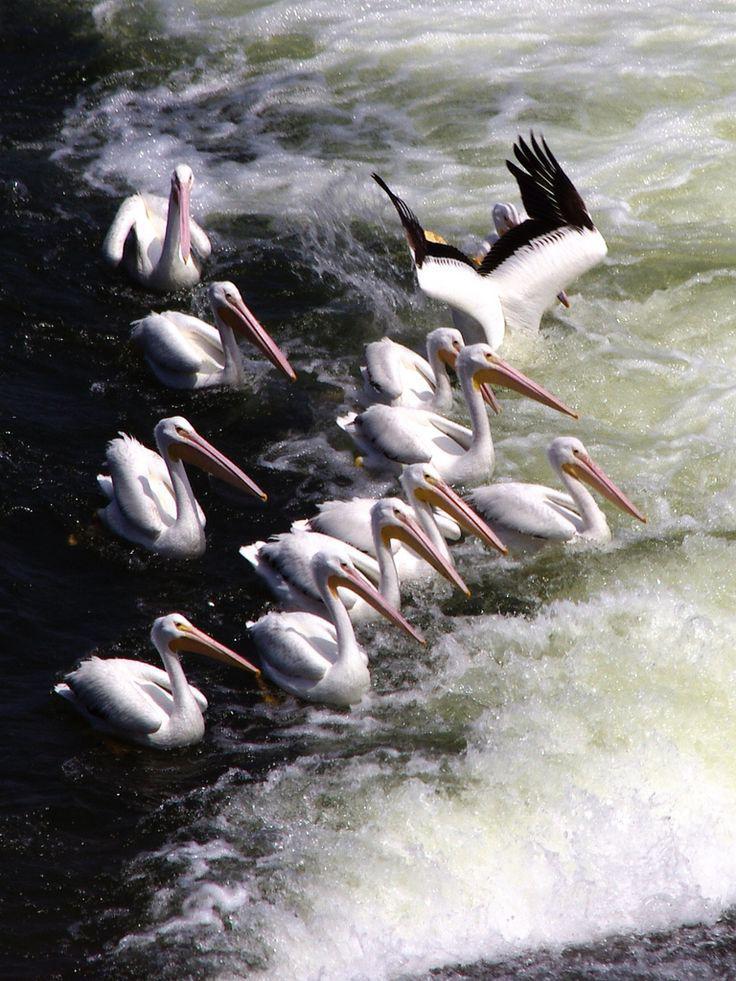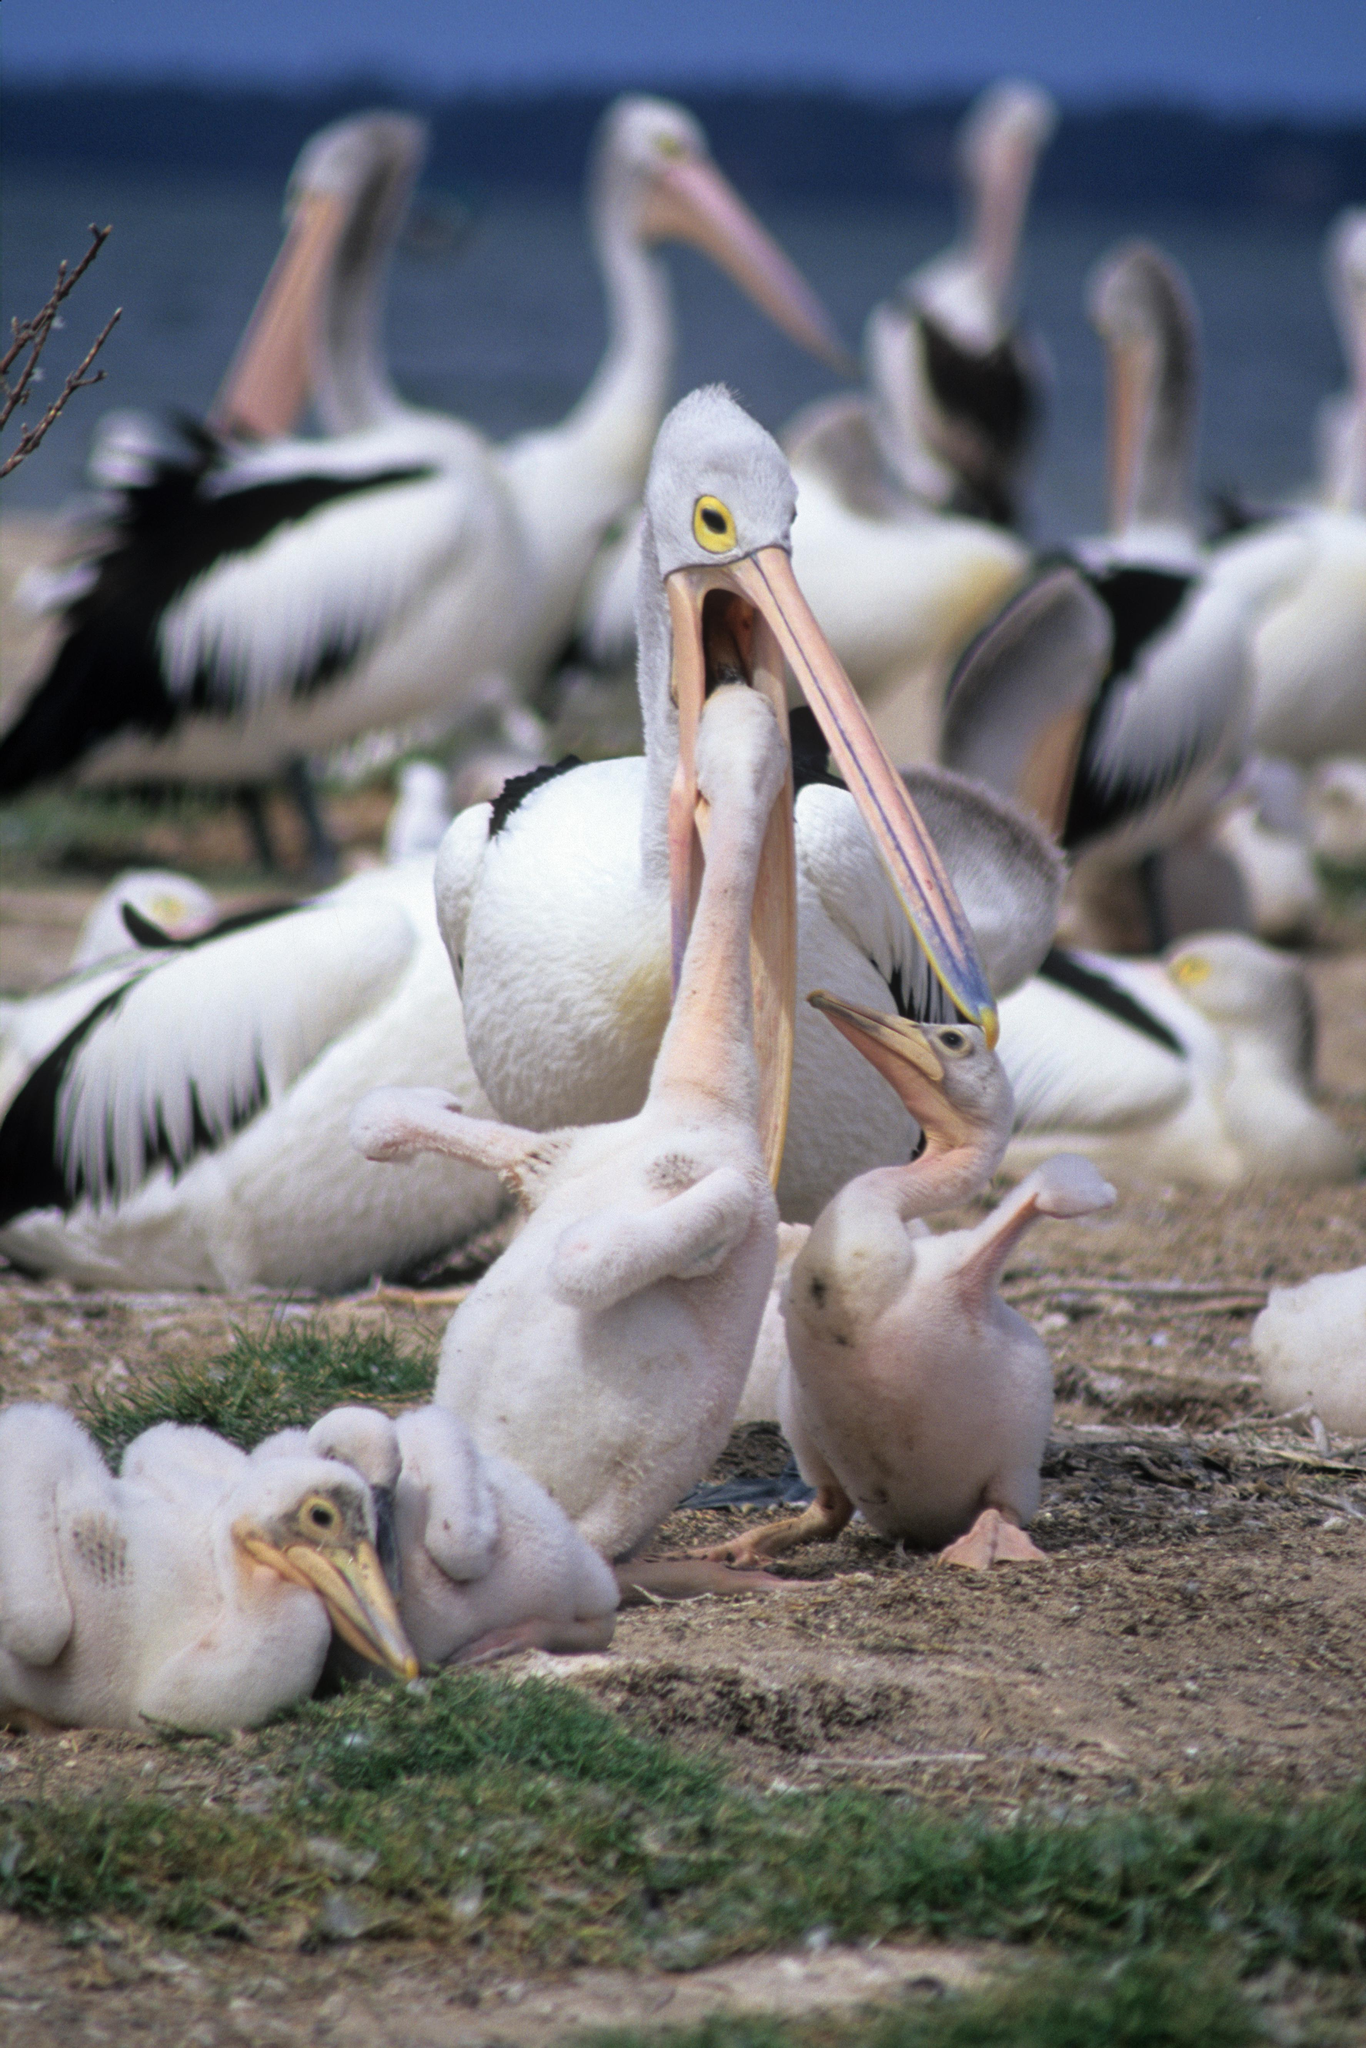The first image is the image on the left, the second image is the image on the right. Evaluate the accuracy of this statement regarding the images: "There is at least one image of one or more pelicans standing on a dock.". Is it true? Answer yes or no. No. The first image is the image on the left, the second image is the image on the right. For the images displayed, is the sentence "There is an animal directly on top of a wooden post." factually correct? Answer yes or no. No. 